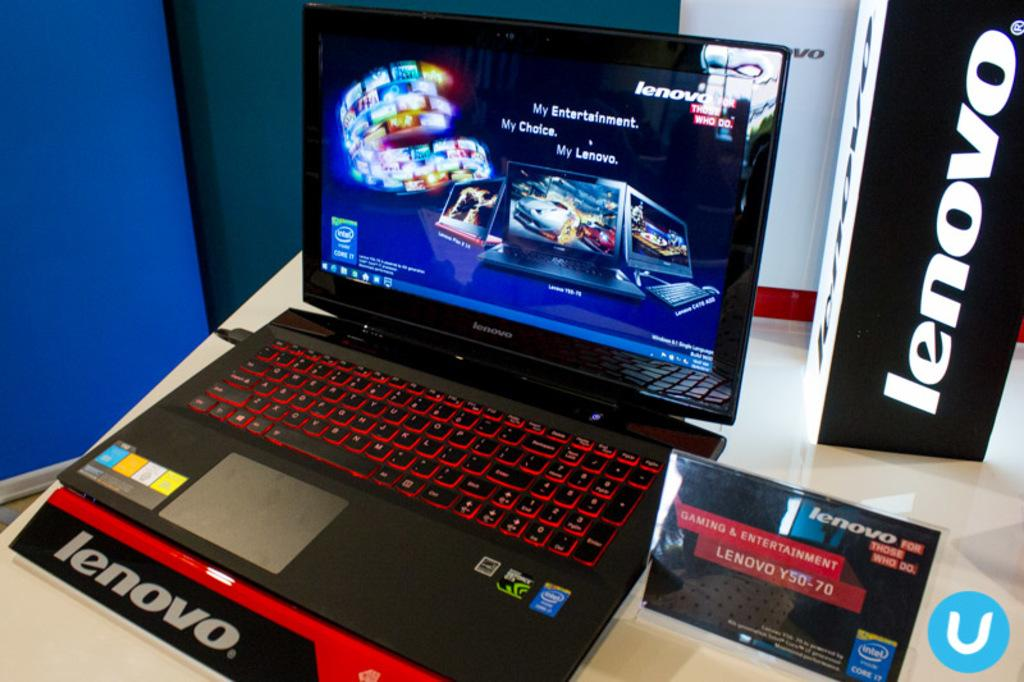<image>
Describe the image concisely. A black Lenovo laptop is on display on a counter in a store. 